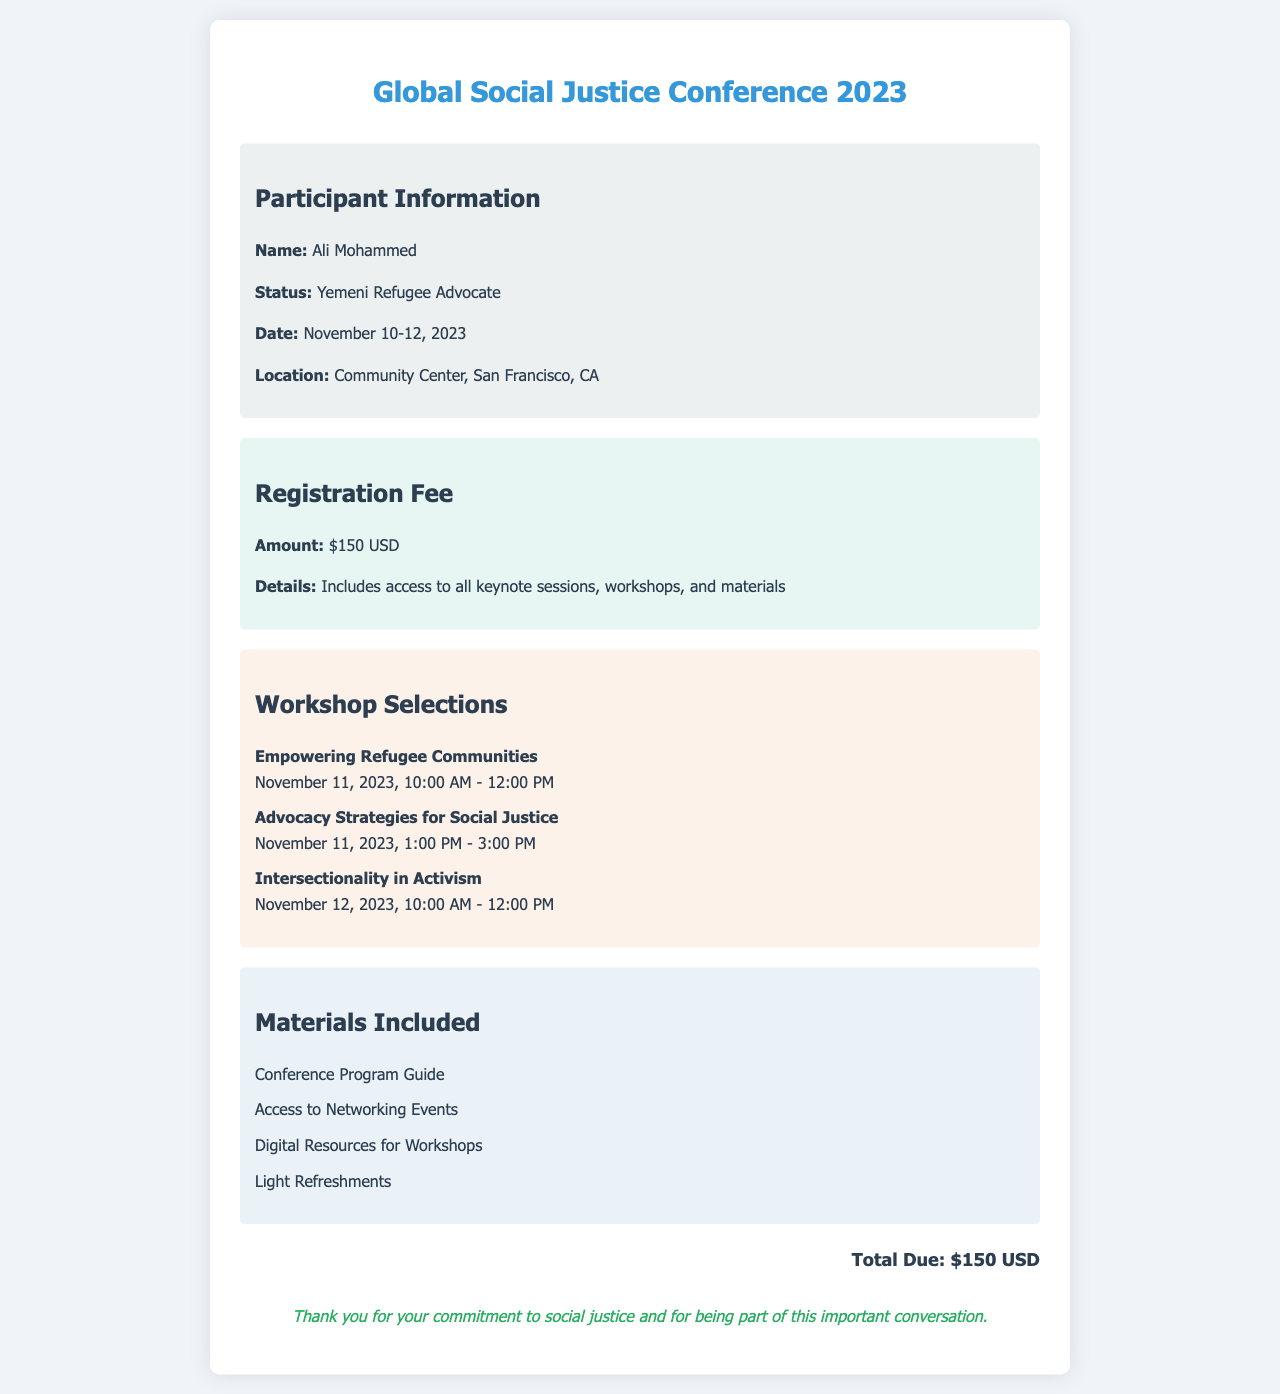What is the registration fee? The registration fee is specified under the fee information section of the document.
Answer: $150 USD Who is the participant? The participant's name is mentioned in the participant information section of the document.
Answer: Ali Mohammed What is the date of the conference? The date is listed in the participant information section of the document.
Answer: November 10-12, 2023 What workshop is scheduled on November 12, 2023? The workshops are listed in the workshop selections section, which helps identify the specific date and workshop.
Answer: Intersectionality in Activism Which materials are included? The materials are detailed in the materials included section, outlining what participants will receive.
Answer: Conference Program Guide, Access to Networking Events, Digital Resources for Workshops, Light Refreshments How many workshops are the participant registered for? Counting the workshops listed in the workshop selections provides the total number.
Answer: 3 Where is the conference being held? The location is specified in the participant information section of the document.
Answer: Community Center, San Francisco, CA What time does the first workshop start? The start time of the first workshop is stated in the workshop selections section, indicating when it begins.
Answer: 10:00 AM 